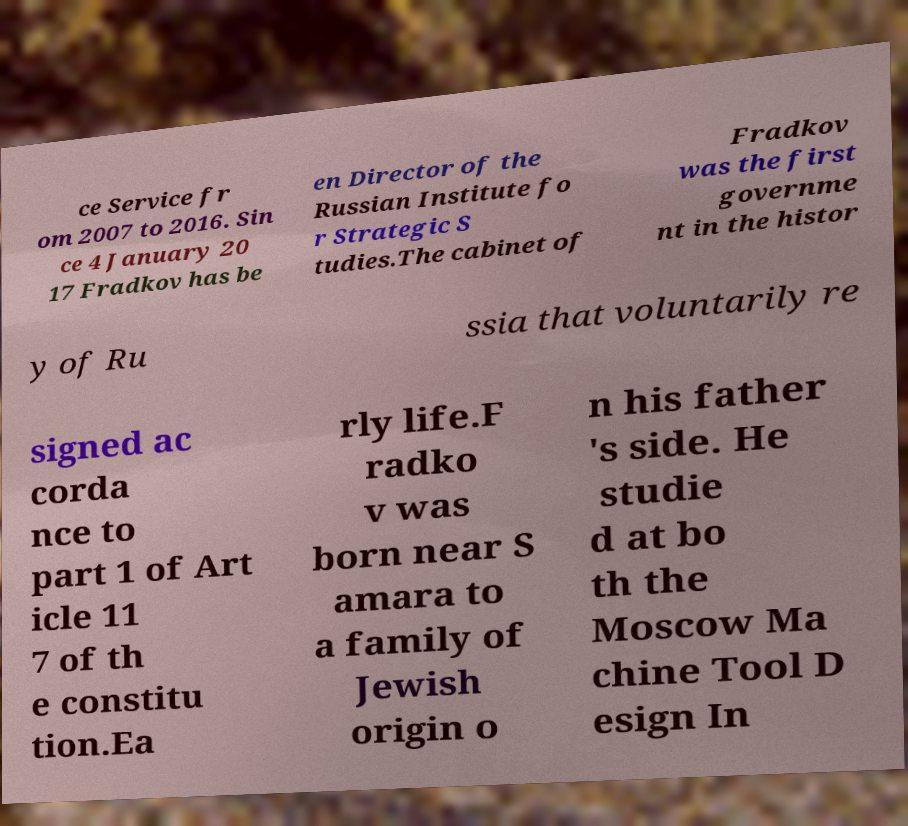Please read and relay the text visible in this image. What does it say? ce Service fr om 2007 to 2016. Sin ce 4 January 20 17 Fradkov has be en Director of the Russian Institute fo r Strategic S tudies.The cabinet of Fradkov was the first governme nt in the histor y of Ru ssia that voluntarily re signed ac corda nce to part 1 of Art icle 11 7 of th e constitu tion.Ea rly life.F radko v was born near S amara to a family of Jewish origin o n his father 's side. He studie d at bo th the Moscow Ma chine Tool D esign In 